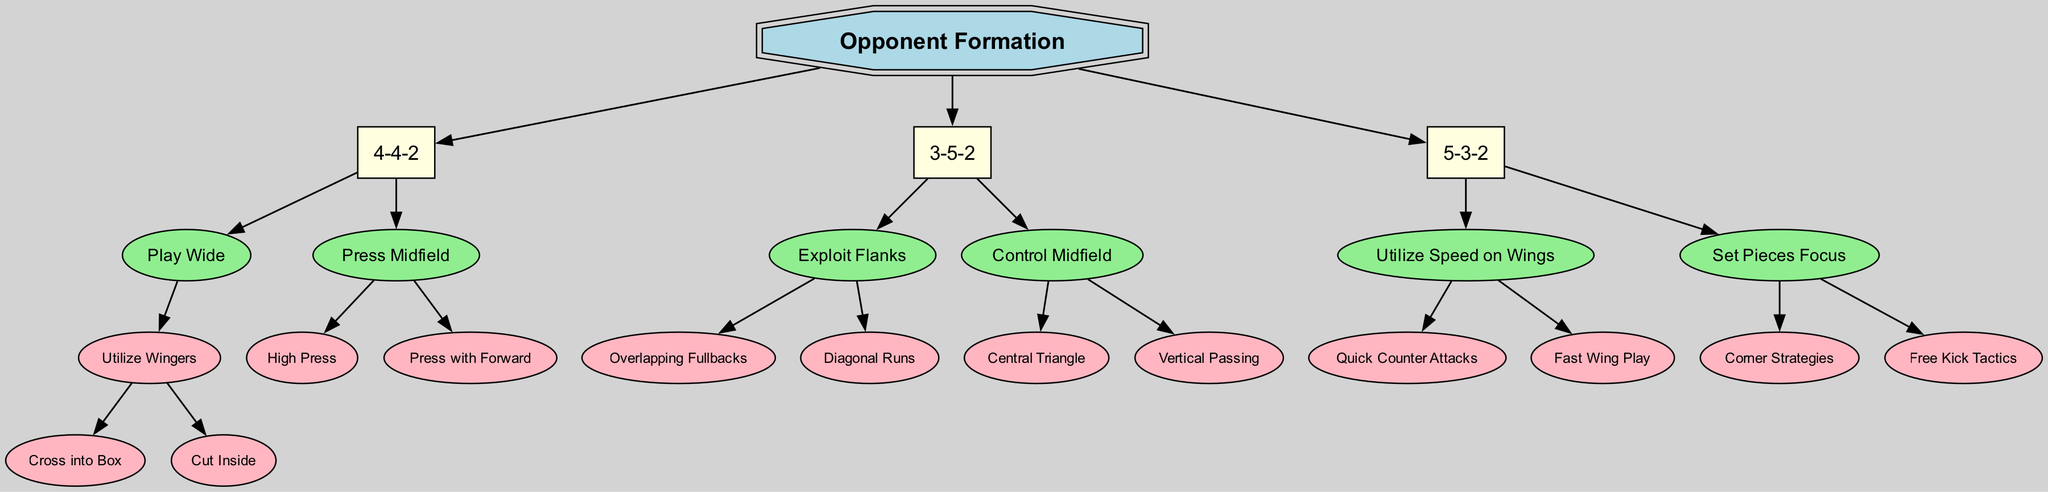What is the root node of this decision tree? The root node is identified clearly as the primary decision point for the diagram, which focuses on the "Opponent Formation."
Answer: Opponent Formation How many strategies are outlined under the 4-4-2 formation? By examining the branches under the "4-4-2" node, it can be seen that there are two main strategies available: "Play Wide" and "Press Midfield."
Answer: 2 What is one tactic under "Utilize Speed on Wings" for the 5-3-2 formation? Looking within the "5-3-2" branch, the strategies lead to "Utilize Speed on Wings," which includes tactics such as "Quick Counter Attacks" and "Fast Wing Play." Choosing one, "Quick Counter Attacks" is a tactic listed.
Answer: Quick Counter Attacks Which formation focuses on set pieces? The "5-3-2" formation specifically suggests a focus on set pieces, indicated by the branch "Set Pieces Focus," which includes sub-tactics like "Corner Strategies" and "Free Kick Tactics."
Answer: 5-3-2 What is the second tactic listed under "Exploit Flanks" in the 3-5-2 formation? Under the "Exploit Flanks" section of the "3-5-2" branch, "Diagonal Runs" is the second tactic mentioned, following "Overlapping Fullbacks."
Answer: Diagonal Runs Which strategy involves pressing the opponents? Under the "4-4-2" formation segment, the "Press Midfield" strategy focuses on pressing, leading to further specific tactics like "High Press" and "Press with Forward."
Answer: Press Midfield How many total formations are represented in this decision tree? By inspecting the first level of the decision tree, we can count three formations: "4-4-2," "3-5-2," and "5-3-2."
Answer: 3 What is the first strategy listed for the 3-5-2 formation? In the "3-5-2" branch of the diagram, the first strategy encountered is "Exploit Flanks," which is the first option presented.
Answer: Exploit Flanks Which formation suggests utilizing wingers? The "4-4-2" formation suggests utilizing wingers, as indicated by the "Utilize Wingers" tactic under the "Play Wide" strategy.
Answer: 4-4-2 